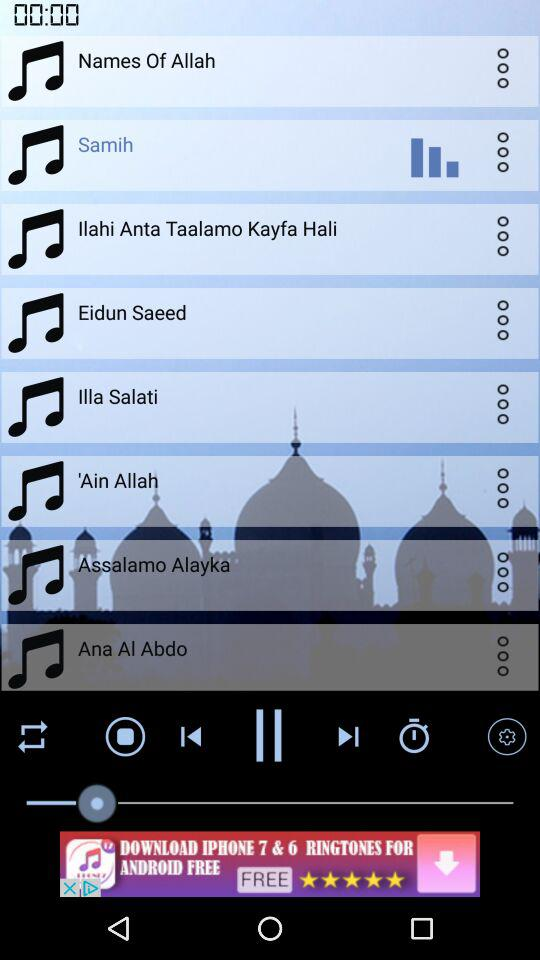What is the name of the prayer? The names of the prayers are "Names Of Allah", "Samih", "Ilahi Anta Taalamo Kayfa Hali", "Eidun Saeed", "Illa Salati", "'Ain Allah", "Assalamo Alayka" and "Ana Al Abdo". 